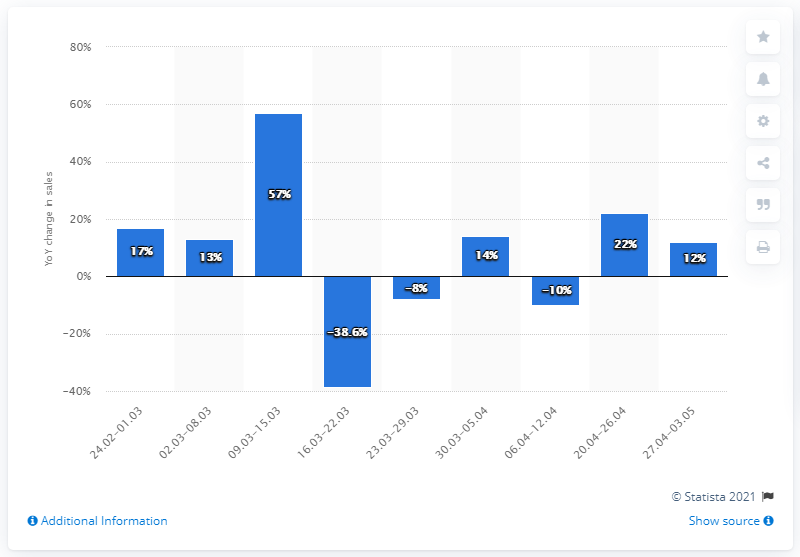Highlight a few significant elements in this photo. The value of the FMCG basket increased by 57% compared to the same week a year earlier. 